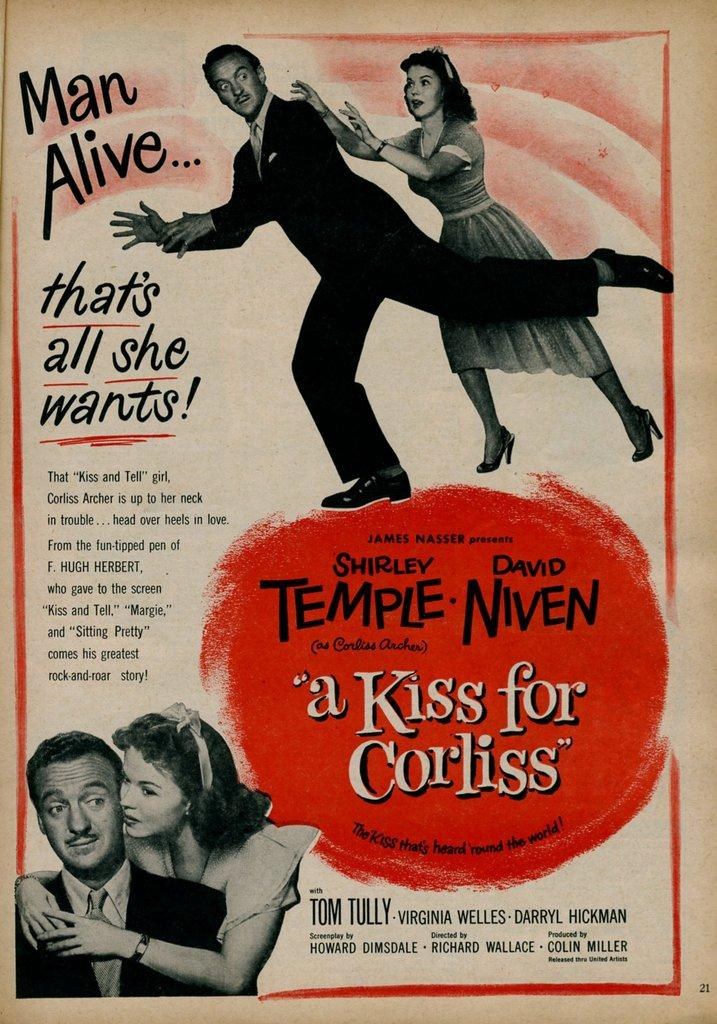<image>
Write a terse but informative summary of the picture. a movie advertisement with a kiss for corliss on it 